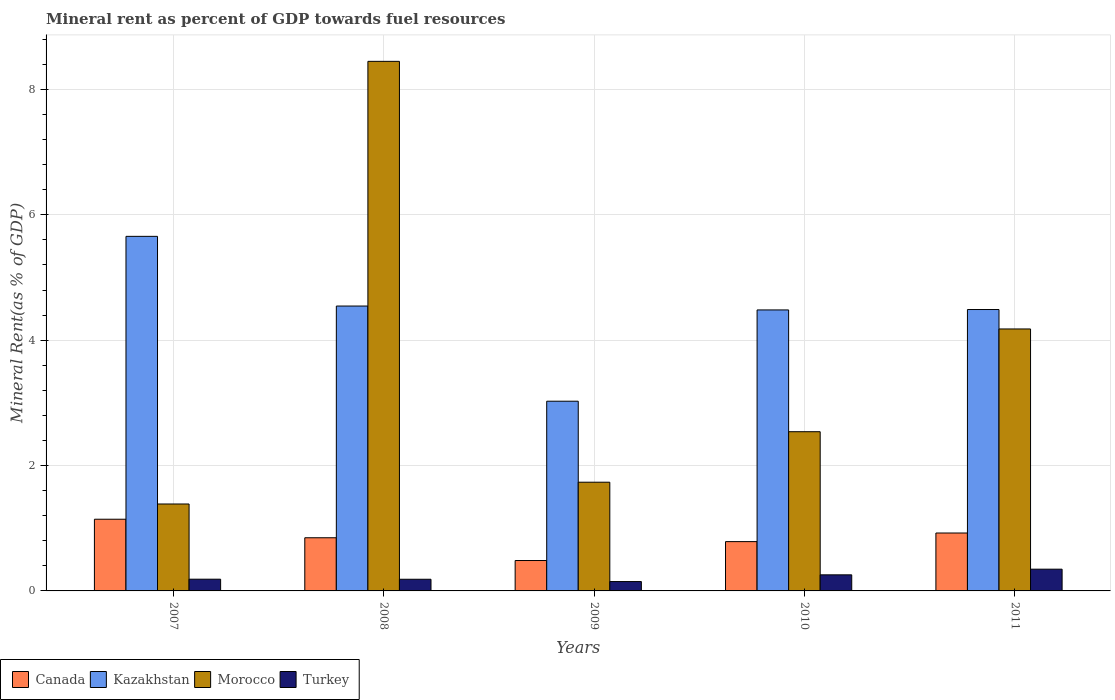Are the number of bars per tick equal to the number of legend labels?
Offer a terse response. Yes. How many bars are there on the 4th tick from the right?
Provide a short and direct response. 4. What is the label of the 4th group of bars from the left?
Your response must be concise. 2010. What is the mineral rent in Morocco in 2011?
Your answer should be compact. 4.18. Across all years, what is the maximum mineral rent in Turkey?
Keep it short and to the point. 0.35. Across all years, what is the minimum mineral rent in Canada?
Ensure brevity in your answer.  0.49. In which year was the mineral rent in Turkey minimum?
Ensure brevity in your answer.  2009. What is the total mineral rent in Turkey in the graph?
Make the answer very short. 1.13. What is the difference between the mineral rent in Turkey in 2007 and that in 2008?
Provide a short and direct response. 0. What is the difference between the mineral rent in Morocco in 2007 and the mineral rent in Kazakhstan in 2011?
Your answer should be very brief. -3.1. What is the average mineral rent in Kazakhstan per year?
Your answer should be compact. 4.44. In the year 2011, what is the difference between the mineral rent in Turkey and mineral rent in Morocco?
Offer a terse response. -3.83. In how many years, is the mineral rent in Morocco greater than 4 %?
Offer a terse response. 2. What is the ratio of the mineral rent in Canada in 2007 to that in 2009?
Provide a succinct answer. 2.36. What is the difference between the highest and the second highest mineral rent in Morocco?
Provide a short and direct response. 4.27. What is the difference between the highest and the lowest mineral rent in Turkey?
Offer a terse response. 0.2. Is the sum of the mineral rent in Morocco in 2008 and 2010 greater than the maximum mineral rent in Canada across all years?
Offer a terse response. Yes. What does the 3rd bar from the left in 2010 represents?
Provide a short and direct response. Morocco. What does the 1st bar from the right in 2009 represents?
Your response must be concise. Turkey. Is it the case that in every year, the sum of the mineral rent in Morocco and mineral rent in Canada is greater than the mineral rent in Turkey?
Give a very brief answer. Yes. How many bars are there?
Provide a succinct answer. 20. What is the difference between two consecutive major ticks on the Y-axis?
Ensure brevity in your answer.  2. What is the title of the graph?
Provide a succinct answer. Mineral rent as percent of GDP towards fuel resources. What is the label or title of the X-axis?
Provide a succinct answer. Years. What is the label or title of the Y-axis?
Your answer should be very brief. Mineral Rent(as % of GDP). What is the Mineral Rent(as % of GDP) of Canada in 2007?
Ensure brevity in your answer.  1.14. What is the Mineral Rent(as % of GDP) of Kazakhstan in 2007?
Give a very brief answer. 5.66. What is the Mineral Rent(as % of GDP) in Morocco in 2007?
Offer a very short reply. 1.39. What is the Mineral Rent(as % of GDP) in Turkey in 2007?
Give a very brief answer. 0.19. What is the Mineral Rent(as % of GDP) of Canada in 2008?
Your answer should be very brief. 0.85. What is the Mineral Rent(as % of GDP) in Kazakhstan in 2008?
Provide a short and direct response. 4.55. What is the Mineral Rent(as % of GDP) in Morocco in 2008?
Provide a succinct answer. 8.45. What is the Mineral Rent(as % of GDP) in Turkey in 2008?
Make the answer very short. 0.19. What is the Mineral Rent(as % of GDP) of Canada in 2009?
Give a very brief answer. 0.49. What is the Mineral Rent(as % of GDP) in Kazakhstan in 2009?
Your response must be concise. 3.03. What is the Mineral Rent(as % of GDP) in Morocco in 2009?
Your answer should be compact. 1.73. What is the Mineral Rent(as % of GDP) in Turkey in 2009?
Ensure brevity in your answer.  0.15. What is the Mineral Rent(as % of GDP) in Canada in 2010?
Offer a terse response. 0.79. What is the Mineral Rent(as % of GDP) of Kazakhstan in 2010?
Keep it short and to the point. 4.48. What is the Mineral Rent(as % of GDP) in Morocco in 2010?
Offer a terse response. 2.54. What is the Mineral Rent(as % of GDP) of Turkey in 2010?
Keep it short and to the point. 0.26. What is the Mineral Rent(as % of GDP) of Canada in 2011?
Provide a short and direct response. 0.92. What is the Mineral Rent(as % of GDP) in Kazakhstan in 2011?
Provide a short and direct response. 4.49. What is the Mineral Rent(as % of GDP) in Morocco in 2011?
Provide a short and direct response. 4.18. What is the Mineral Rent(as % of GDP) in Turkey in 2011?
Your response must be concise. 0.35. Across all years, what is the maximum Mineral Rent(as % of GDP) of Canada?
Provide a succinct answer. 1.14. Across all years, what is the maximum Mineral Rent(as % of GDP) of Kazakhstan?
Your response must be concise. 5.66. Across all years, what is the maximum Mineral Rent(as % of GDP) of Morocco?
Make the answer very short. 8.45. Across all years, what is the maximum Mineral Rent(as % of GDP) of Turkey?
Ensure brevity in your answer.  0.35. Across all years, what is the minimum Mineral Rent(as % of GDP) of Canada?
Ensure brevity in your answer.  0.49. Across all years, what is the minimum Mineral Rent(as % of GDP) in Kazakhstan?
Provide a succinct answer. 3.03. Across all years, what is the minimum Mineral Rent(as % of GDP) in Morocco?
Provide a short and direct response. 1.39. Across all years, what is the minimum Mineral Rent(as % of GDP) of Turkey?
Offer a very short reply. 0.15. What is the total Mineral Rent(as % of GDP) in Canada in the graph?
Your answer should be compact. 4.19. What is the total Mineral Rent(as % of GDP) of Kazakhstan in the graph?
Your answer should be very brief. 22.2. What is the total Mineral Rent(as % of GDP) in Morocco in the graph?
Provide a short and direct response. 18.29. What is the total Mineral Rent(as % of GDP) of Turkey in the graph?
Your answer should be very brief. 1.13. What is the difference between the Mineral Rent(as % of GDP) of Canada in 2007 and that in 2008?
Give a very brief answer. 0.3. What is the difference between the Mineral Rent(as % of GDP) in Kazakhstan in 2007 and that in 2008?
Give a very brief answer. 1.11. What is the difference between the Mineral Rent(as % of GDP) of Morocco in 2007 and that in 2008?
Keep it short and to the point. -7.06. What is the difference between the Mineral Rent(as % of GDP) of Turkey in 2007 and that in 2008?
Ensure brevity in your answer.  0. What is the difference between the Mineral Rent(as % of GDP) in Canada in 2007 and that in 2009?
Make the answer very short. 0.66. What is the difference between the Mineral Rent(as % of GDP) in Kazakhstan in 2007 and that in 2009?
Provide a succinct answer. 2.63. What is the difference between the Mineral Rent(as % of GDP) in Morocco in 2007 and that in 2009?
Keep it short and to the point. -0.35. What is the difference between the Mineral Rent(as % of GDP) in Turkey in 2007 and that in 2009?
Give a very brief answer. 0.04. What is the difference between the Mineral Rent(as % of GDP) in Canada in 2007 and that in 2010?
Ensure brevity in your answer.  0.36. What is the difference between the Mineral Rent(as % of GDP) of Kazakhstan in 2007 and that in 2010?
Offer a terse response. 1.17. What is the difference between the Mineral Rent(as % of GDP) in Morocco in 2007 and that in 2010?
Your answer should be compact. -1.15. What is the difference between the Mineral Rent(as % of GDP) in Turkey in 2007 and that in 2010?
Offer a terse response. -0.07. What is the difference between the Mineral Rent(as % of GDP) in Canada in 2007 and that in 2011?
Your answer should be compact. 0.22. What is the difference between the Mineral Rent(as % of GDP) of Kazakhstan in 2007 and that in 2011?
Offer a very short reply. 1.17. What is the difference between the Mineral Rent(as % of GDP) in Morocco in 2007 and that in 2011?
Ensure brevity in your answer.  -2.79. What is the difference between the Mineral Rent(as % of GDP) of Turkey in 2007 and that in 2011?
Offer a terse response. -0.16. What is the difference between the Mineral Rent(as % of GDP) of Canada in 2008 and that in 2009?
Ensure brevity in your answer.  0.36. What is the difference between the Mineral Rent(as % of GDP) of Kazakhstan in 2008 and that in 2009?
Provide a short and direct response. 1.52. What is the difference between the Mineral Rent(as % of GDP) of Morocco in 2008 and that in 2009?
Offer a terse response. 6.71. What is the difference between the Mineral Rent(as % of GDP) in Turkey in 2008 and that in 2009?
Make the answer very short. 0.04. What is the difference between the Mineral Rent(as % of GDP) in Canada in 2008 and that in 2010?
Keep it short and to the point. 0.06. What is the difference between the Mineral Rent(as % of GDP) in Kazakhstan in 2008 and that in 2010?
Your answer should be very brief. 0.06. What is the difference between the Mineral Rent(as % of GDP) in Morocco in 2008 and that in 2010?
Keep it short and to the point. 5.91. What is the difference between the Mineral Rent(as % of GDP) in Turkey in 2008 and that in 2010?
Give a very brief answer. -0.07. What is the difference between the Mineral Rent(as % of GDP) of Canada in 2008 and that in 2011?
Your answer should be very brief. -0.08. What is the difference between the Mineral Rent(as % of GDP) in Kazakhstan in 2008 and that in 2011?
Your answer should be very brief. 0.06. What is the difference between the Mineral Rent(as % of GDP) of Morocco in 2008 and that in 2011?
Give a very brief answer. 4.27. What is the difference between the Mineral Rent(as % of GDP) of Turkey in 2008 and that in 2011?
Keep it short and to the point. -0.16. What is the difference between the Mineral Rent(as % of GDP) of Canada in 2009 and that in 2010?
Keep it short and to the point. -0.3. What is the difference between the Mineral Rent(as % of GDP) in Kazakhstan in 2009 and that in 2010?
Provide a short and direct response. -1.46. What is the difference between the Mineral Rent(as % of GDP) of Morocco in 2009 and that in 2010?
Offer a terse response. -0.81. What is the difference between the Mineral Rent(as % of GDP) in Turkey in 2009 and that in 2010?
Provide a succinct answer. -0.11. What is the difference between the Mineral Rent(as % of GDP) in Canada in 2009 and that in 2011?
Offer a terse response. -0.44. What is the difference between the Mineral Rent(as % of GDP) of Kazakhstan in 2009 and that in 2011?
Offer a terse response. -1.46. What is the difference between the Mineral Rent(as % of GDP) in Morocco in 2009 and that in 2011?
Your answer should be very brief. -2.45. What is the difference between the Mineral Rent(as % of GDP) in Turkey in 2009 and that in 2011?
Keep it short and to the point. -0.2. What is the difference between the Mineral Rent(as % of GDP) of Canada in 2010 and that in 2011?
Provide a succinct answer. -0.14. What is the difference between the Mineral Rent(as % of GDP) in Kazakhstan in 2010 and that in 2011?
Provide a succinct answer. -0.01. What is the difference between the Mineral Rent(as % of GDP) in Morocco in 2010 and that in 2011?
Offer a very short reply. -1.64. What is the difference between the Mineral Rent(as % of GDP) in Turkey in 2010 and that in 2011?
Provide a short and direct response. -0.09. What is the difference between the Mineral Rent(as % of GDP) of Canada in 2007 and the Mineral Rent(as % of GDP) of Kazakhstan in 2008?
Provide a succinct answer. -3.4. What is the difference between the Mineral Rent(as % of GDP) of Canada in 2007 and the Mineral Rent(as % of GDP) of Morocco in 2008?
Offer a very short reply. -7.31. What is the difference between the Mineral Rent(as % of GDP) of Canada in 2007 and the Mineral Rent(as % of GDP) of Turkey in 2008?
Provide a succinct answer. 0.96. What is the difference between the Mineral Rent(as % of GDP) in Kazakhstan in 2007 and the Mineral Rent(as % of GDP) in Morocco in 2008?
Your answer should be compact. -2.79. What is the difference between the Mineral Rent(as % of GDP) of Kazakhstan in 2007 and the Mineral Rent(as % of GDP) of Turkey in 2008?
Ensure brevity in your answer.  5.47. What is the difference between the Mineral Rent(as % of GDP) in Morocco in 2007 and the Mineral Rent(as % of GDP) in Turkey in 2008?
Offer a terse response. 1.2. What is the difference between the Mineral Rent(as % of GDP) in Canada in 2007 and the Mineral Rent(as % of GDP) in Kazakhstan in 2009?
Your response must be concise. -1.88. What is the difference between the Mineral Rent(as % of GDP) of Canada in 2007 and the Mineral Rent(as % of GDP) of Morocco in 2009?
Keep it short and to the point. -0.59. What is the difference between the Mineral Rent(as % of GDP) of Kazakhstan in 2007 and the Mineral Rent(as % of GDP) of Morocco in 2009?
Provide a succinct answer. 3.92. What is the difference between the Mineral Rent(as % of GDP) in Kazakhstan in 2007 and the Mineral Rent(as % of GDP) in Turkey in 2009?
Make the answer very short. 5.51. What is the difference between the Mineral Rent(as % of GDP) in Morocco in 2007 and the Mineral Rent(as % of GDP) in Turkey in 2009?
Keep it short and to the point. 1.24. What is the difference between the Mineral Rent(as % of GDP) of Canada in 2007 and the Mineral Rent(as % of GDP) of Kazakhstan in 2010?
Ensure brevity in your answer.  -3.34. What is the difference between the Mineral Rent(as % of GDP) of Canada in 2007 and the Mineral Rent(as % of GDP) of Morocco in 2010?
Your answer should be very brief. -1.4. What is the difference between the Mineral Rent(as % of GDP) in Canada in 2007 and the Mineral Rent(as % of GDP) in Turkey in 2010?
Your response must be concise. 0.89. What is the difference between the Mineral Rent(as % of GDP) in Kazakhstan in 2007 and the Mineral Rent(as % of GDP) in Morocco in 2010?
Provide a succinct answer. 3.12. What is the difference between the Mineral Rent(as % of GDP) in Kazakhstan in 2007 and the Mineral Rent(as % of GDP) in Turkey in 2010?
Your response must be concise. 5.4. What is the difference between the Mineral Rent(as % of GDP) of Morocco in 2007 and the Mineral Rent(as % of GDP) of Turkey in 2010?
Your answer should be very brief. 1.13. What is the difference between the Mineral Rent(as % of GDP) of Canada in 2007 and the Mineral Rent(as % of GDP) of Kazakhstan in 2011?
Keep it short and to the point. -3.35. What is the difference between the Mineral Rent(as % of GDP) of Canada in 2007 and the Mineral Rent(as % of GDP) of Morocco in 2011?
Offer a very short reply. -3.04. What is the difference between the Mineral Rent(as % of GDP) in Canada in 2007 and the Mineral Rent(as % of GDP) in Turkey in 2011?
Your response must be concise. 0.8. What is the difference between the Mineral Rent(as % of GDP) of Kazakhstan in 2007 and the Mineral Rent(as % of GDP) of Morocco in 2011?
Make the answer very short. 1.48. What is the difference between the Mineral Rent(as % of GDP) in Kazakhstan in 2007 and the Mineral Rent(as % of GDP) in Turkey in 2011?
Provide a succinct answer. 5.31. What is the difference between the Mineral Rent(as % of GDP) of Morocco in 2007 and the Mineral Rent(as % of GDP) of Turkey in 2011?
Your response must be concise. 1.04. What is the difference between the Mineral Rent(as % of GDP) of Canada in 2008 and the Mineral Rent(as % of GDP) of Kazakhstan in 2009?
Keep it short and to the point. -2.18. What is the difference between the Mineral Rent(as % of GDP) in Canada in 2008 and the Mineral Rent(as % of GDP) in Morocco in 2009?
Make the answer very short. -0.89. What is the difference between the Mineral Rent(as % of GDP) in Canada in 2008 and the Mineral Rent(as % of GDP) in Turkey in 2009?
Make the answer very short. 0.7. What is the difference between the Mineral Rent(as % of GDP) in Kazakhstan in 2008 and the Mineral Rent(as % of GDP) in Morocco in 2009?
Provide a short and direct response. 2.81. What is the difference between the Mineral Rent(as % of GDP) in Kazakhstan in 2008 and the Mineral Rent(as % of GDP) in Turkey in 2009?
Your answer should be compact. 4.4. What is the difference between the Mineral Rent(as % of GDP) of Morocco in 2008 and the Mineral Rent(as % of GDP) of Turkey in 2009?
Keep it short and to the point. 8.3. What is the difference between the Mineral Rent(as % of GDP) in Canada in 2008 and the Mineral Rent(as % of GDP) in Kazakhstan in 2010?
Provide a short and direct response. -3.63. What is the difference between the Mineral Rent(as % of GDP) of Canada in 2008 and the Mineral Rent(as % of GDP) of Morocco in 2010?
Provide a succinct answer. -1.69. What is the difference between the Mineral Rent(as % of GDP) in Canada in 2008 and the Mineral Rent(as % of GDP) in Turkey in 2010?
Give a very brief answer. 0.59. What is the difference between the Mineral Rent(as % of GDP) in Kazakhstan in 2008 and the Mineral Rent(as % of GDP) in Morocco in 2010?
Make the answer very short. 2.01. What is the difference between the Mineral Rent(as % of GDP) of Kazakhstan in 2008 and the Mineral Rent(as % of GDP) of Turkey in 2010?
Keep it short and to the point. 4.29. What is the difference between the Mineral Rent(as % of GDP) of Morocco in 2008 and the Mineral Rent(as % of GDP) of Turkey in 2010?
Offer a terse response. 8.19. What is the difference between the Mineral Rent(as % of GDP) in Canada in 2008 and the Mineral Rent(as % of GDP) in Kazakhstan in 2011?
Provide a succinct answer. -3.64. What is the difference between the Mineral Rent(as % of GDP) in Canada in 2008 and the Mineral Rent(as % of GDP) in Morocco in 2011?
Keep it short and to the point. -3.33. What is the difference between the Mineral Rent(as % of GDP) of Canada in 2008 and the Mineral Rent(as % of GDP) of Turkey in 2011?
Keep it short and to the point. 0.5. What is the difference between the Mineral Rent(as % of GDP) in Kazakhstan in 2008 and the Mineral Rent(as % of GDP) in Morocco in 2011?
Make the answer very short. 0.37. What is the difference between the Mineral Rent(as % of GDP) of Kazakhstan in 2008 and the Mineral Rent(as % of GDP) of Turkey in 2011?
Provide a short and direct response. 4.2. What is the difference between the Mineral Rent(as % of GDP) of Morocco in 2008 and the Mineral Rent(as % of GDP) of Turkey in 2011?
Give a very brief answer. 8.1. What is the difference between the Mineral Rent(as % of GDP) of Canada in 2009 and the Mineral Rent(as % of GDP) of Kazakhstan in 2010?
Ensure brevity in your answer.  -4. What is the difference between the Mineral Rent(as % of GDP) of Canada in 2009 and the Mineral Rent(as % of GDP) of Morocco in 2010?
Provide a short and direct response. -2.06. What is the difference between the Mineral Rent(as % of GDP) of Canada in 2009 and the Mineral Rent(as % of GDP) of Turkey in 2010?
Provide a short and direct response. 0.23. What is the difference between the Mineral Rent(as % of GDP) of Kazakhstan in 2009 and the Mineral Rent(as % of GDP) of Morocco in 2010?
Give a very brief answer. 0.49. What is the difference between the Mineral Rent(as % of GDP) of Kazakhstan in 2009 and the Mineral Rent(as % of GDP) of Turkey in 2010?
Offer a very short reply. 2.77. What is the difference between the Mineral Rent(as % of GDP) of Morocco in 2009 and the Mineral Rent(as % of GDP) of Turkey in 2010?
Ensure brevity in your answer.  1.48. What is the difference between the Mineral Rent(as % of GDP) of Canada in 2009 and the Mineral Rent(as % of GDP) of Kazakhstan in 2011?
Your answer should be very brief. -4. What is the difference between the Mineral Rent(as % of GDP) in Canada in 2009 and the Mineral Rent(as % of GDP) in Morocco in 2011?
Provide a succinct answer. -3.69. What is the difference between the Mineral Rent(as % of GDP) in Canada in 2009 and the Mineral Rent(as % of GDP) in Turkey in 2011?
Offer a very short reply. 0.14. What is the difference between the Mineral Rent(as % of GDP) in Kazakhstan in 2009 and the Mineral Rent(as % of GDP) in Morocco in 2011?
Make the answer very short. -1.15. What is the difference between the Mineral Rent(as % of GDP) in Kazakhstan in 2009 and the Mineral Rent(as % of GDP) in Turkey in 2011?
Make the answer very short. 2.68. What is the difference between the Mineral Rent(as % of GDP) of Morocco in 2009 and the Mineral Rent(as % of GDP) of Turkey in 2011?
Give a very brief answer. 1.39. What is the difference between the Mineral Rent(as % of GDP) of Canada in 2010 and the Mineral Rent(as % of GDP) of Kazakhstan in 2011?
Offer a terse response. -3.7. What is the difference between the Mineral Rent(as % of GDP) of Canada in 2010 and the Mineral Rent(as % of GDP) of Morocco in 2011?
Ensure brevity in your answer.  -3.39. What is the difference between the Mineral Rent(as % of GDP) in Canada in 2010 and the Mineral Rent(as % of GDP) in Turkey in 2011?
Your answer should be very brief. 0.44. What is the difference between the Mineral Rent(as % of GDP) in Kazakhstan in 2010 and the Mineral Rent(as % of GDP) in Morocco in 2011?
Provide a short and direct response. 0.3. What is the difference between the Mineral Rent(as % of GDP) in Kazakhstan in 2010 and the Mineral Rent(as % of GDP) in Turkey in 2011?
Provide a short and direct response. 4.14. What is the difference between the Mineral Rent(as % of GDP) of Morocco in 2010 and the Mineral Rent(as % of GDP) of Turkey in 2011?
Keep it short and to the point. 2.19. What is the average Mineral Rent(as % of GDP) of Canada per year?
Provide a succinct answer. 0.84. What is the average Mineral Rent(as % of GDP) of Kazakhstan per year?
Your answer should be compact. 4.44. What is the average Mineral Rent(as % of GDP) of Morocco per year?
Offer a terse response. 3.66. What is the average Mineral Rent(as % of GDP) in Turkey per year?
Give a very brief answer. 0.23. In the year 2007, what is the difference between the Mineral Rent(as % of GDP) of Canada and Mineral Rent(as % of GDP) of Kazakhstan?
Offer a very short reply. -4.51. In the year 2007, what is the difference between the Mineral Rent(as % of GDP) in Canada and Mineral Rent(as % of GDP) in Morocco?
Your answer should be very brief. -0.24. In the year 2007, what is the difference between the Mineral Rent(as % of GDP) in Canada and Mineral Rent(as % of GDP) in Turkey?
Make the answer very short. 0.96. In the year 2007, what is the difference between the Mineral Rent(as % of GDP) of Kazakhstan and Mineral Rent(as % of GDP) of Morocco?
Your response must be concise. 4.27. In the year 2007, what is the difference between the Mineral Rent(as % of GDP) of Kazakhstan and Mineral Rent(as % of GDP) of Turkey?
Provide a short and direct response. 5.47. In the year 2007, what is the difference between the Mineral Rent(as % of GDP) of Morocco and Mineral Rent(as % of GDP) of Turkey?
Your answer should be very brief. 1.2. In the year 2008, what is the difference between the Mineral Rent(as % of GDP) of Canada and Mineral Rent(as % of GDP) of Kazakhstan?
Ensure brevity in your answer.  -3.7. In the year 2008, what is the difference between the Mineral Rent(as % of GDP) of Canada and Mineral Rent(as % of GDP) of Morocco?
Ensure brevity in your answer.  -7.6. In the year 2008, what is the difference between the Mineral Rent(as % of GDP) of Canada and Mineral Rent(as % of GDP) of Turkey?
Keep it short and to the point. 0.66. In the year 2008, what is the difference between the Mineral Rent(as % of GDP) in Kazakhstan and Mineral Rent(as % of GDP) in Morocco?
Your answer should be compact. -3.9. In the year 2008, what is the difference between the Mineral Rent(as % of GDP) in Kazakhstan and Mineral Rent(as % of GDP) in Turkey?
Offer a terse response. 4.36. In the year 2008, what is the difference between the Mineral Rent(as % of GDP) of Morocco and Mineral Rent(as % of GDP) of Turkey?
Keep it short and to the point. 8.26. In the year 2009, what is the difference between the Mineral Rent(as % of GDP) in Canada and Mineral Rent(as % of GDP) in Kazakhstan?
Provide a short and direct response. -2.54. In the year 2009, what is the difference between the Mineral Rent(as % of GDP) in Canada and Mineral Rent(as % of GDP) in Morocco?
Make the answer very short. -1.25. In the year 2009, what is the difference between the Mineral Rent(as % of GDP) in Canada and Mineral Rent(as % of GDP) in Turkey?
Give a very brief answer. 0.34. In the year 2009, what is the difference between the Mineral Rent(as % of GDP) in Kazakhstan and Mineral Rent(as % of GDP) in Morocco?
Keep it short and to the point. 1.29. In the year 2009, what is the difference between the Mineral Rent(as % of GDP) of Kazakhstan and Mineral Rent(as % of GDP) of Turkey?
Your answer should be very brief. 2.88. In the year 2009, what is the difference between the Mineral Rent(as % of GDP) of Morocco and Mineral Rent(as % of GDP) of Turkey?
Offer a terse response. 1.58. In the year 2010, what is the difference between the Mineral Rent(as % of GDP) in Canada and Mineral Rent(as % of GDP) in Kazakhstan?
Ensure brevity in your answer.  -3.7. In the year 2010, what is the difference between the Mineral Rent(as % of GDP) of Canada and Mineral Rent(as % of GDP) of Morocco?
Your response must be concise. -1.75. In the year 2010, what is the difference between the Mineral Rent(as % of GDP) in Canada and Mineral Rent(as % of GDP) in Turkey?
Your response must be concise. 0.53. In the year 2010, what is the difference between the Mineral Rent(as % of GDP) of Kazakhstan and Mineral Rent(as % of GDP) of Morocco?
Offer a very short reply. 1.94. In the year 2010, what is the difference between the Mineral Rent(as % of GDP) in Kazakhstan and Mineral Rent(as % of GDP) in Turkey?
Give a very brief answer. 4.23. In the year 2010, what is the difference between the Mineral Rent(as % of GDP) in Morocco and Mineral Rent(as % of GDP) in Turkey?
Offer a terse response. 2.28. In the year 2011, what is the difference between the Mineral Rent(as % of GDP) in Canada and Mineral Rent(as % of GDP) in Kazakhstan?
Provide a succinct answer. -3.57. In the year 2011, what is the difference between the Mineral Rent(as % of GDP) of Canada and Mineral Rent(as % of GDP) of Morocco?
Provide a succinct answer. -3.26. In the year 2011, what is the difference between the Mineral Rent(as % of GDP) in Canada and Mineral Rent(as % of GDP) in Turkey?
Offer a terse response. 0.58. In the year 2011, what is the difference between the Mineral Rent(as % of GDP) of Kazakhstan and Mineral Rent(as % of GDP) of Morocco?
Offer a terse response. 0.31. In the year 2011, what is the difference between the Mineral Rent(as % of GDP) in Kazakhstan and Mineral Rent(as % of GDP) in Turkey?
Your answer should be very brief. 4.14. In the year 2011, what is the difference between the Mineral Rent(as % of GDP) of Morocco and Mineral Rent(as % of GDP) of Turkey?
Make the answer very short. 3.83. What is the ratio of the Mineral Rent(as % of GDP) in Canada in 2007 to that in 2008?
Ensure brevity in your answer.  1.35. What is the ratio of the Mineral Rent(as % of GDP) of Kazakhstan in 2007 to that in 2008?
Your response must be concise. 1.24. What is the ratio of the Mineral Rent(as % of GDP) in Morocco in 2007 to that in 2008?
Make the answer very short. 0.16. What is the ratio of the Mineral Rent(as % of GDP) of Turkey in 2007 to that in 2008?
Your response must be concise. 1.01. What is the ratio of the Mineral Rent(as % of GDP) in Canada in 2007 to that in 2009?
Ensure brevity in your answer.  2.36. What is the ratio of the Mineral Rent(as % of GDP) of Kazakhstan in 2007 to that in 2009?
Offer a terse response. 1.87. What is the ratio of the Mineral Rent(as % of GDP) of Morocco in 2007 to that in 2009?
Your answer should be very brief. 0.8. What is the ratio of the Mineral Rent(as % of GDP) in Turkey in 2007 to that in 2009?
Provide a short and direct response. 1.25. What is the ratio of the Mineral Rent(as % of GDP) of Canada in 2007 to that in 2010?
Provide a short and direct response. 1.45. What is the ratio of the Mineral Rent(as % of GDP) of Kazakhstan in 2007 to that in 2010?
Ensure brevity in your answer.  1.26. What is the ratio of the Mineral Rent(as % of GDP) in Morocco in 2007 to that in 2010?
Offer a very short reply. 0.55. What is the ratio of the Mineral Rent(as % of GDP) in Turkey in 2007 to that in 2010?
Your answer should be very brief. 0.73. What is the ratio of the Mineral Rent(as % of GDP) in Canada in 2007 to that in 2011?
Provide a short and direct response. 1.24. What is the ratio of the Mineral Rent(as % of GDP) in Kazakhstan in 2007 to that in 2011?
Ensure brevity in your answer.  1.26. What is the ratio of the Mineral Rent(as % of GDP) in Morocco in 2007 to that in 2011?
Offer a very short reply. 0.33. What is the ratio of the Mineral Rent(as % of GDP) of Turkey in 2007 to that in 2011?
Offer a very short reply. 0.54. What is the ratio of the Mineral Rent(as % of GDP) in Canada in 2008 to that in 2009?
Your answer should be very brief. 1.75. What is the ratio of the Mineral Rent(as % of GDP) in Kazakhstan in 2008 to that in 2009?
Your response must be concise. 1.5. What is the ratio of the Mineral Rent(as % of GDP) of Morocco in 2008 to that in 2009?
Your response must be concise. 4.87. What is the ratio of the Mineral Rent(as % of GDP) of Turkey in 2008 to that in 2009?
Your response must be concise. 1.25. What is the ratio of the Mineral Rent(as % of GDP) of Canada in 2008 to that in 2010?
Provide a succinct answer. 1.08. What is the ratio of the Mineral Rent(as % of GDP) in Kazakhstan in 2008 to that in 2010?
Your response must be concise. 1.01. What is the ratio of the Mineral Rent(as % of GDP) in Morocco in 2008 to that in 2010?
Your response must be concise. 3.33. What is the ratio of the Mineral Rent(as % of GDP) in Turkey in 2008 to that in 2010?
Offer a very short reply. 0.73. What is the ratio of the Mineral Rent(as % of GDP) in Canada in 2008 to that in 2011?
Your answer should be compact. 0.92. What is the ratio of the Mineral Rent(as % of GDP) of Kazakhstan in 2008 to that in 2011?
Offer a very short reply. 1.01. What is the ratio of the Mineral Rent(as % of GDP) of Morocco in 2008 to that in 2011?
Provide a short and direct response. 2.02. What is the ratio of the Mineral Rent(as % of GDP) of Turkey in 2008 to that in 2011?
Offer a very short reply. 0.54. What is the ratio of the Mineral Rent(as % of GDP) of Canada in 2009 to that in 2010?
Your answer should be very brief. 0.62. What is the ratio of the Mineral Rent(as % of GDP) of Kazakhstan in 2009 to that in 2010?
Make the answer very short. 0.68. What is the ratio of the Mineral Rent(as % of GDP) of Morocco in 2009 to that in 2010?
Provide a short and direct response. 0.68. What is the ratio of the Mineral Rent(as % of GDP) of Turkey in 2009 to that in 2010?
Keep it short and to the point. 0.58. What is the ratio of the Mineral Rent(as % of GDP) of Canada in 2009 to that in 2011?
Give a very brief answer. 0.52. What is the ratio of the Mineral Rent(as % of GDP) in Kazakhstan in 2009 to that in 2011?
Offer a terse response. 0.67. What is the ratio of the Mineral Rent(as % of GDP) of Morocco in 2009 to that in 2011?
Offer a terse response. 0.41. What is the ratio of the Mineral Rent(as % of GDP) of Turkey in 2009 to that in 2011?
Give a very brief answer. 0.43. What is the ratio of the Mineral Rent(as % of GDP) in Canada in 2010 to that in 2011?
Your answer should be compact. 0.85. What is the ratio of the Mineral Rent(as % of GDP) of Morocco in 2010 to that in 2011?
Provide a succinct answer. 0.61. What is the ratio of the Mineral Rent(as % of GDP) in Turkey in 2010 to that in 2011?
Give a very brief answer. 0.74. What is the difference between the highest and the second highest Mineral Rent(as % of GDP) in Canada?
Keep it short and to the point. 0.22. What is the difference between the highest and the second highest Mineral Rent(as % of GDP) of Kazakhstan?
Your answer should be compact. 1.11. What is the difference between the highest and the second highest Mineral Rent(as % of GDP) of Morocco?
Provide a succinct answer. 4.27. What is the difference between the highest and the second highest Mineral Rent(as % of GDP) in Turkey?
Give a very brief answer. 0.09. What is the difference between the highest and the lowest Mineral Rent(as % of GDP) in Canada?
Your answer should be compact. 0.66. What is the difference between the highest and the lowest Mineral Rent(as % of GDP) of Kazakhstan?
Provide a short and direct response. 2.63. What is the difference between the highest and the lowest Mineral Rent(as % of GDP) of Morocco?
Your answer should be compact. 7.06. What is the difference between the highest and the lowest Mineral Rent(as % of GDP) of Turkey?
Your answer should be very brief. 0.2. 